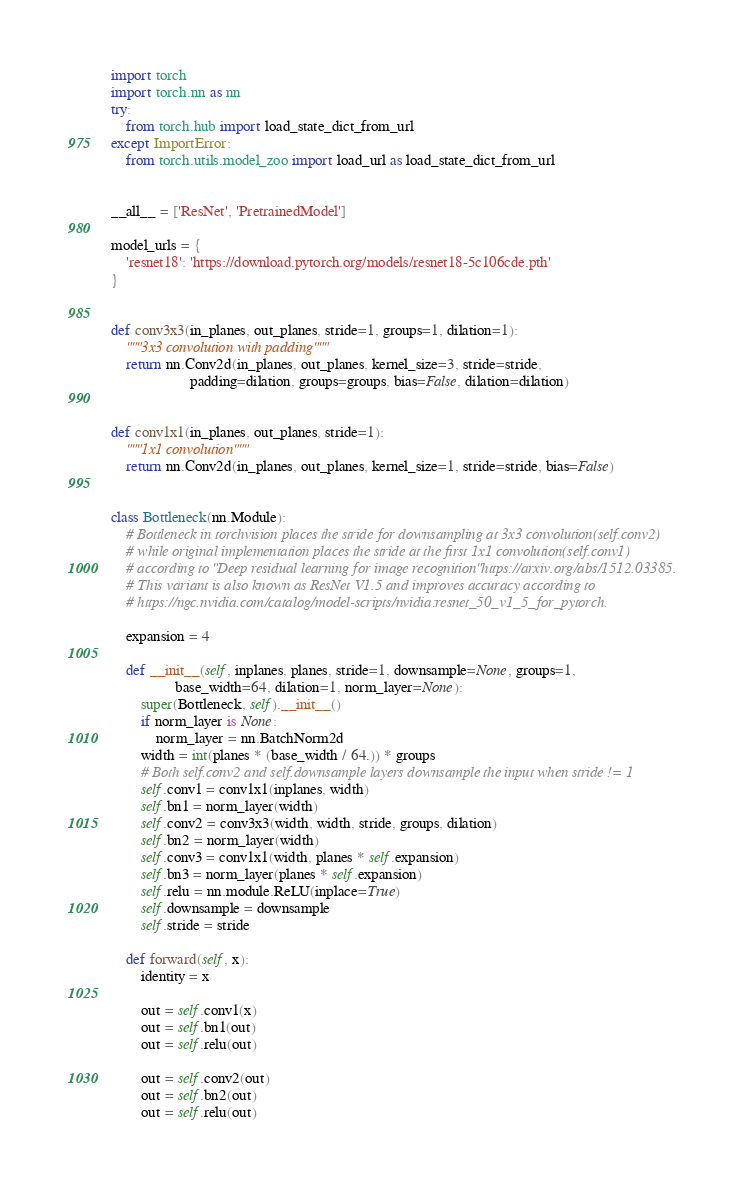<code> <loc_0><loc_0><loc_500><loc_500><_Python_>import torch
import torch.nn as nn
try:
    from torch.hub import load_state_dict_from_url
except ImportError:
    from torch.utils.model_zoo import load_url as load_state_dict_from_url


__all__ = ['ResNet', 'PretrainedModel']

model_urls = {
    'resnet18': 'https://download.pytorch.org/models/resnet18-5c106cde.pth'
}


def conv3x3(in_planes, out_planes, stride=1, groups=1, dilation=1):
    """3x3 convolution with padding"""
    return nn.Conv2d(in_planes, out_planes, kernel_size=3, stride=stride,
                     padding=dilation, groups=groups, bias=False, dilation=dilation)


def conv1x1(in_planes, out_planes, stride=1):
    """1x1 convolution"""
    return nn.Conv2d(in_planes, out_planes, kernel_size=1, stride=stride, bias=False)


class Bottleneck(nn.Module):
    # Bottleneck in torchvision places the stride for downsampling at 3x3 convolution(self.conv2)
    # while original implementation places the stride at the first 1x1 convolution(self.conv1)
    # according to "Deep residual learning for image recognition"https://arxiv.org/abs/1512.03385.
    # This variant is also known as ResNet V1.5 and improves accuracy according to
    # https://ngc.nvidia.com/catalog/model-scripts/nvidia:resnet_50_v1_5_for_pytorch.

    expansion = 4

    def __init__(self, inplanes, planes, stride=1, downsample=None, groups=1,
                 base_width=64, dilation=1, norm_layer=None):
        super(Bottleneck, self).__init__()
        if norm_layer is None:
            norm_layer = nn.BatchNorm2d
        width = int(planes * (base_width / 64.)) * groups
        # Both self.conv2 and self.downsample layers downsample the input when stride != 1
        self.conv1 = conv1x1(inplanes, width)
        self.bn1 = norm_layer(width)
        self.conv2 = conv3x3(width, width, stride, groups, dilation)
        self.bn2 = norm_layer(width)
        self.conv3 = conv1x1(width, planes * self.expansion)
        self.bn3 = norm_layer(planes * self.expansion)
        self.relu = nn.module.ReLU(inplace=True)
        self.downsample = downsample
        self.stride = stride

    def forward(self, x):
        identity = x

        out = self.conv1(x)
        out = self.bn1(out)
        out = self.relu(out)

        out = self.conv2(out)
        out = self.bn2(out)
        out = self.relu(out)
</code> 